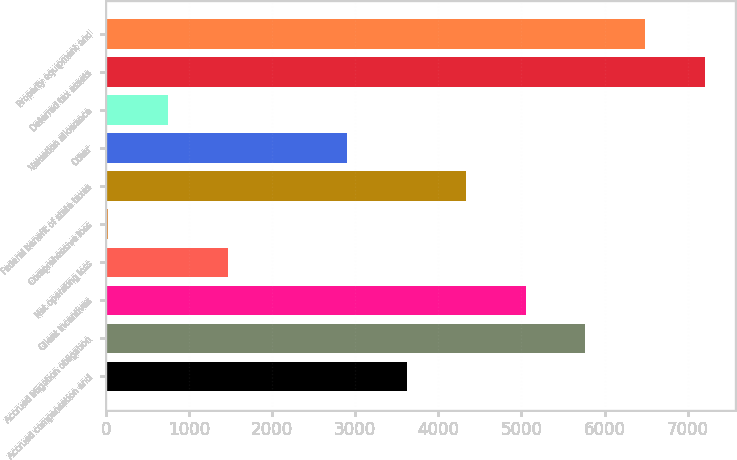Convert chart. <chart><loc_0><loc_0><loc_500><loc_500><bar_chart><fcel>Accrued compensation and<fcel>Accrued litigation obligation<fcel>Client incentives<fcel>Net operating loss<fcel>Comprehensive loss<fcel>Federal benefit of state taxes<fcel>Other<fcel>Valuation allowance<fcel>Deferred tax assets<fcel>Property equipment and<nl><fcel>3617.5<fcel>5770.6<fcel>5052.9<fcel>1464.4<fcel>29<fcel>4335.2<fcel>2899.8<fcel>746.7<fcel>7206<fcel>6488.3<nl></chart> 